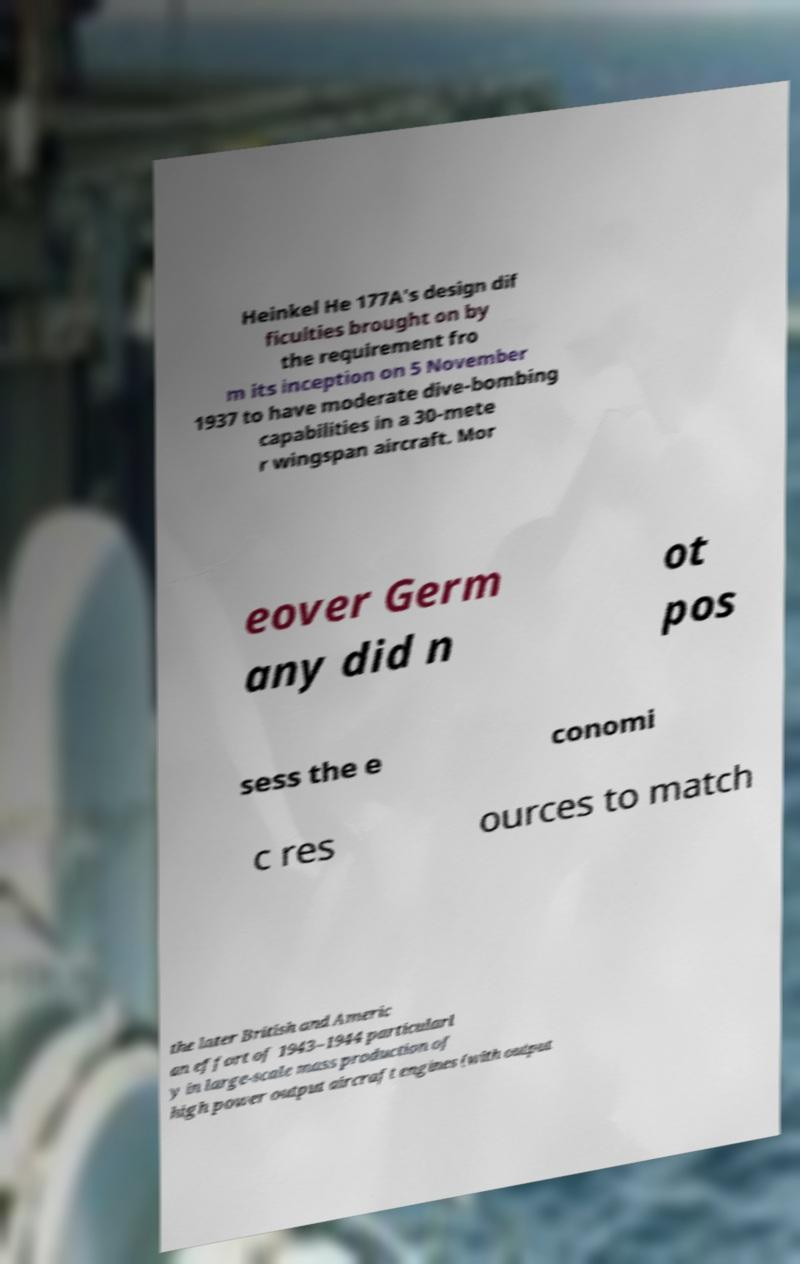Can you read and provide the text displayed in the image?This photo seems to have some interesting text. Can you extract and type it out for me? Heinkel He 177A's design dif ficulties brought on by the requirement fro m its inception on 5 November 1937 to have moderate dive-bombing capabilities in a 30-mete r wingspan aircraft. Mor eover Germ any did n ot pos sess the e conomi c res ources to match the later British and Americ an effort of 1943–1944 particularl y in large-scale mass production of high power output aircraft engines (with output 